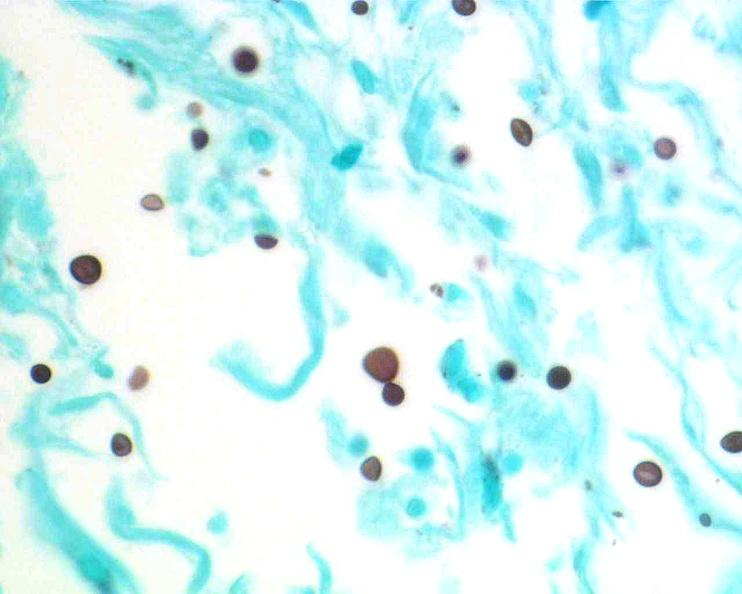does chloramphenicol toxicity show brain, cryptococcal meningitis?
Answer the question using a single word or phrase. No 